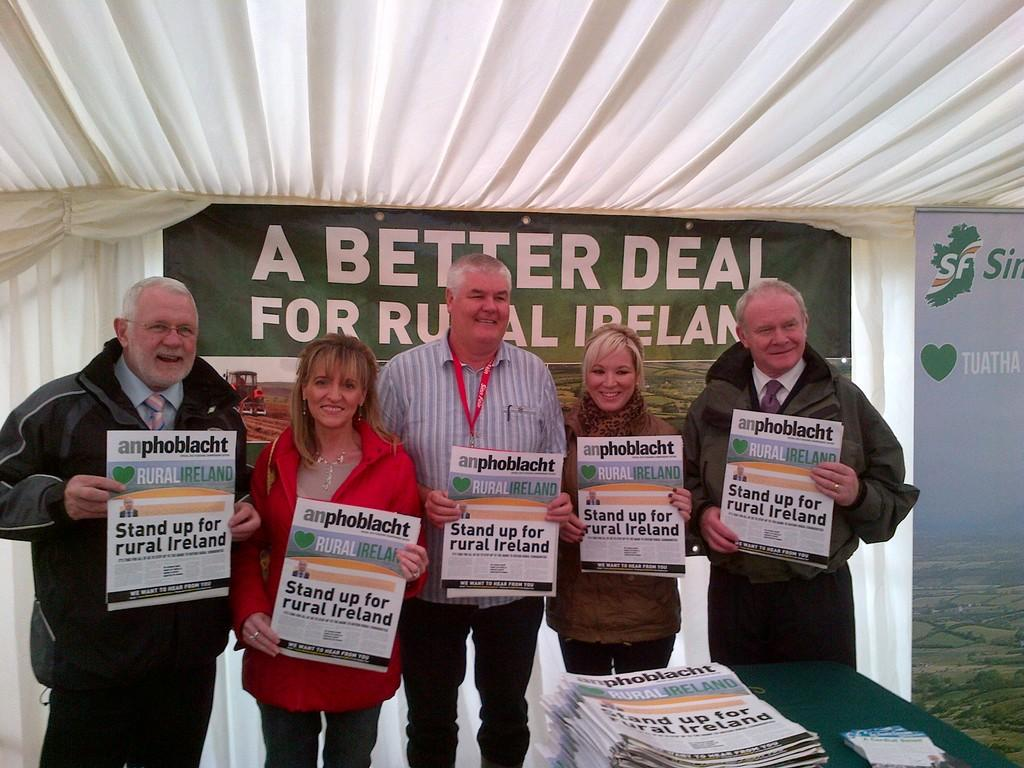What are the people in the image doing? The people in the image are standing and holding paper. What is the purpose of the table in the image? The table is present in the image to hold papers. Can you describe the papers on the table? There are papers placed on the table. What type of heat source can be seen in the image? There is no heat source present in the image. Can you describe the beetle crawling on the table in the image? There is no beetle present in the image. 